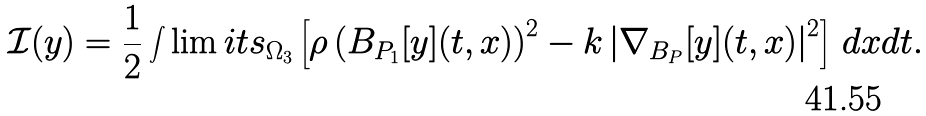Convert formula to latex. <formula><loc_0><loc_0><loc_500><loc_500>\mathcal { I } ( y ) = \frac { 1 } { 2 } \int \lim i t s _ { \Omega _ { 3 } } \left [ \rho \left ( B _ { P _ { 1 } } [ y ] ( t , x ) \right ) ^ { 2 } - k \left | \nabla _ { B _ { P } } [ y ] ( t , x ) \right | ^ { 2 } \right ] \, d x d t .</formula> 